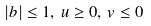Convert formula to latex. <formula><loc_0><loc_0><loc_500><loc_500>| b | \leq 1 , \, u \geq 0 , \, v \leq 0</formula> 